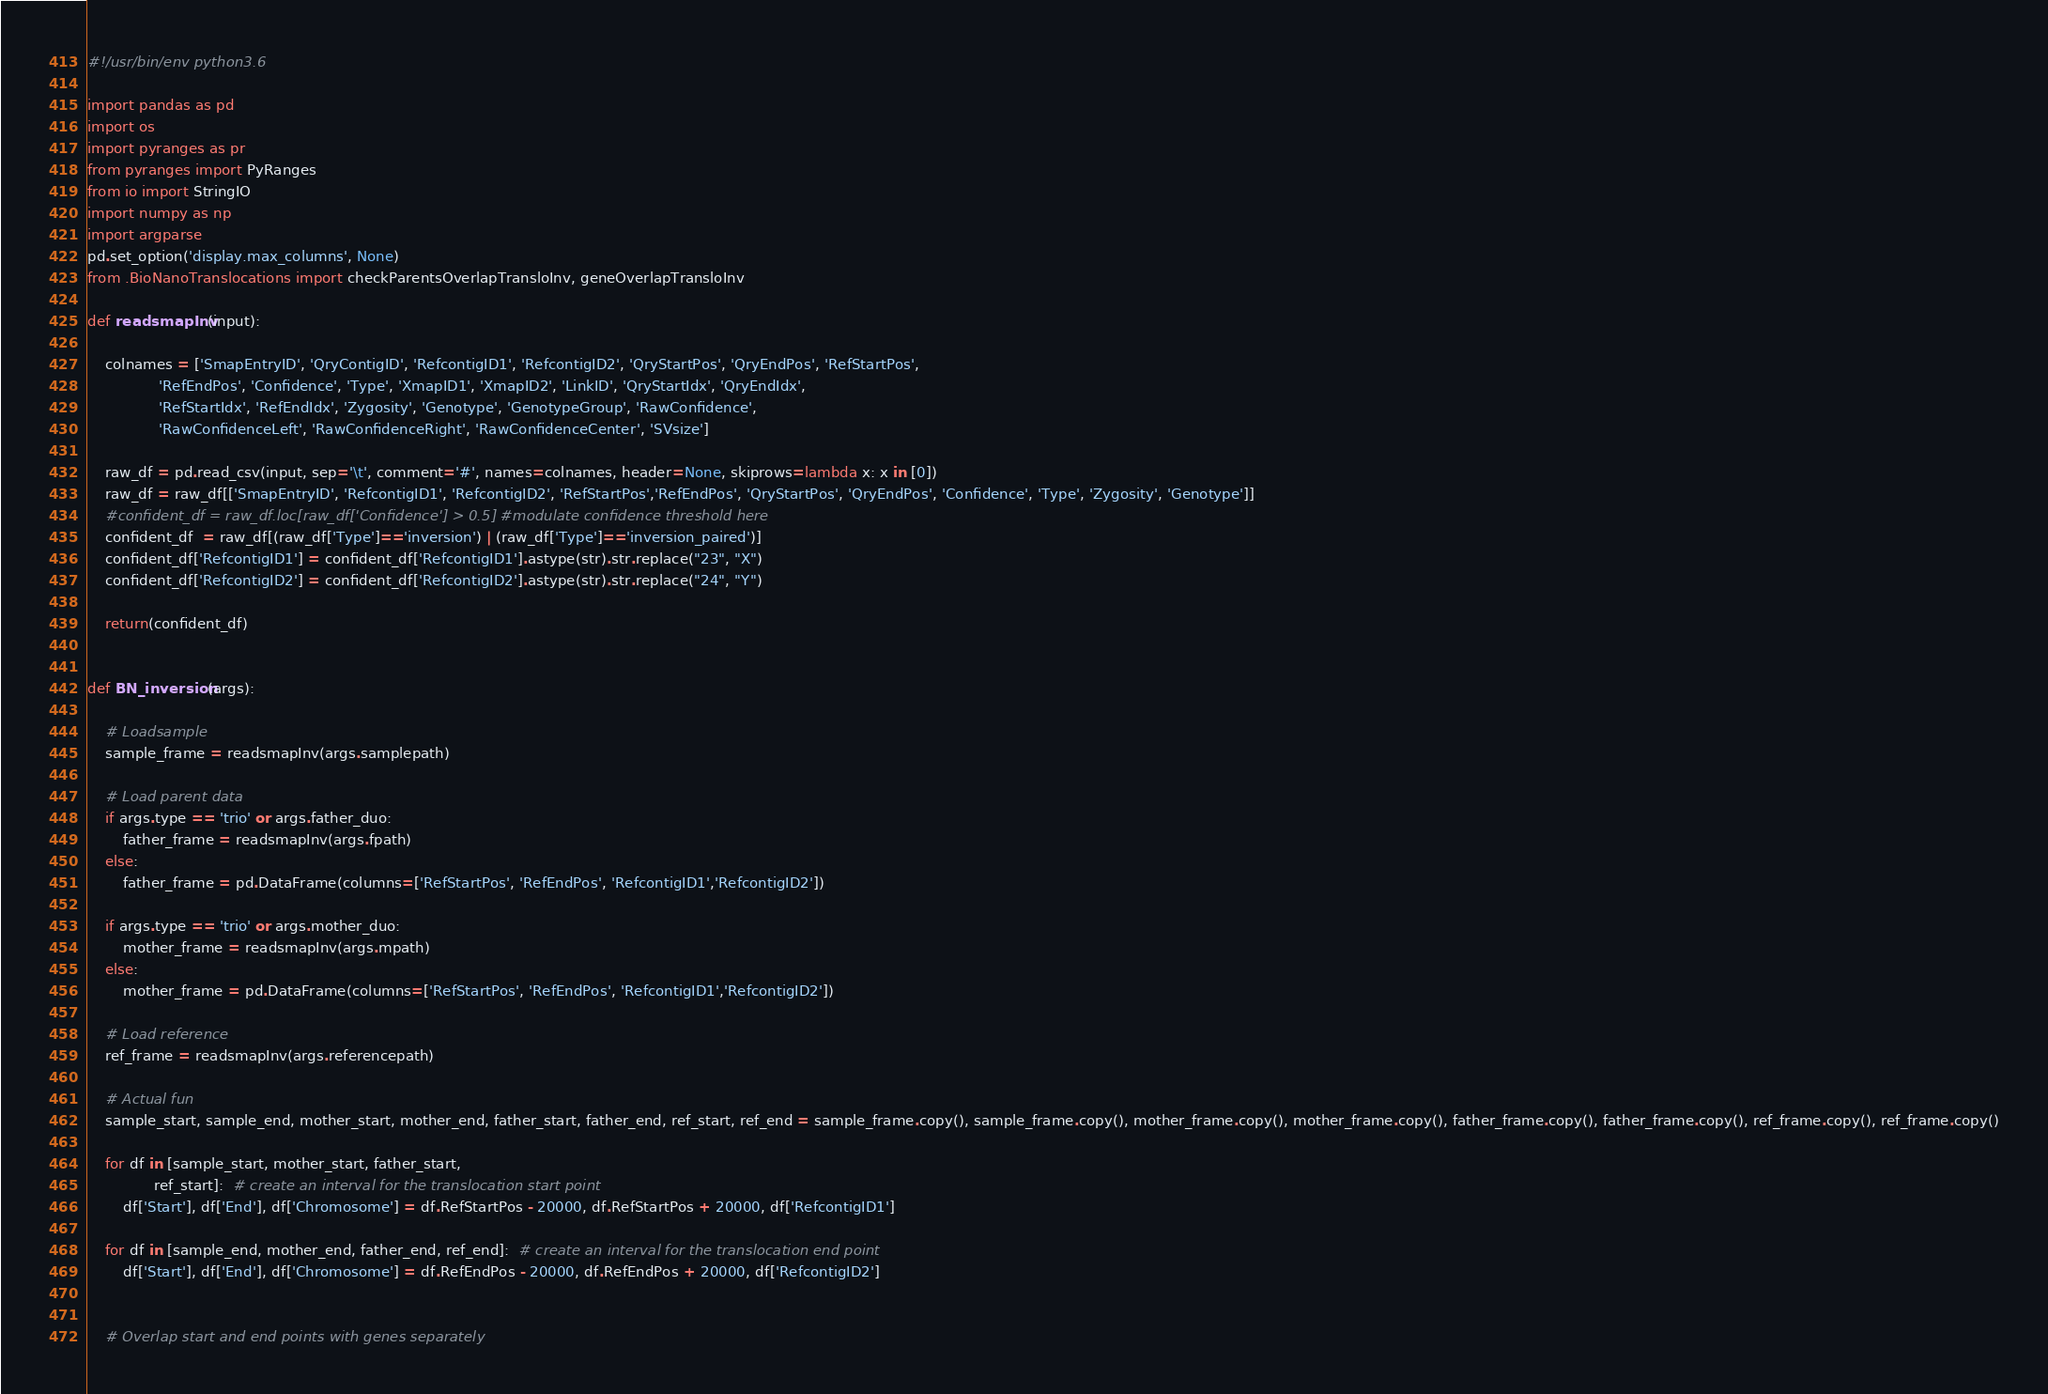Convert code to text. <code><loc_0><loc_0><loc_500><loc_500><_Python_>#!/usr/bin/env python3.6
  
import pandas as pd
import os
import pyranges as pr
from pyranges import PyRanges
from io import StringIO
import numpy as np
import argparse
pd.set_option('display.max_columns', None)
from .BioNanoTranslocations import checkParentsOverlapTransloInv, geneOverlapTransloInv

def readsmapInv(input):

    colnames = ['SmapEntryID', 'QryContigID', 'RefcontigID1', 'RefcontigID2', 'QryStartPos', 'QryEndPos', 'RefStartPos',
                'RefEndPos', 'Confidence', 'Type', 'XmapID1', 'XmapID2', 'LinkID', 'QryStartIdx', 'QryEndIdx',
                'RefStartIdx', 'RefEndIdx', 'Zygosity', 'Genotype', 'GenotypeGroup', 'RawConfidence',
                'RawConfidenceLeft', 'RawConfidenceRight', 'RawConfidenceCenter', 'SVsize']

    raw_df = pd.read_csv(input, sep='\t', comment='#', names=colnames, header=None, skiprows=lambda x: x in [0])
    raw_df = raw_df[['SmapEntryID', 'RefcontigID1', 'RefcontigID2', 'RefStartPos','RefEndPos', 'QryStartPos', 'QryEndPos', 'Confidence', 'Type', 'Zygosity', 'Genotype']]
    #confident_df = raw_df.loc[raw_df['Confidence'] > 0.5] #modulate confidence threshold here
    confident_df  = raw_df[(raw_df['Type']=='inversion') | (raw_df['Type']=='inversion_paired')]
    confident_df['RefcontigID1'] = confident_df['RefcontigID1'].astype(str).str.replace("23", "X")
    confident_df['RefcontigID2'] = confident_df['RefcontigID2'].astype(str).str.replace("24", "Y")

    return(confident_df)


def BN_inversion(args):

    # Loadsample
    sample_frame = readsmapInv(args.samplepath)

    # Load parent data
    if args.type == 'trio' or args.father_duo:
        father_frame = readsmapInv(args.fpath)
    else:
        father_frame = pd.DataFrame(columns=['RefStartPos', 'RefEndPos', 'RefcontigID1','RefcontigID2'])

    if args.type == 'trio' or args.mother_duo:
        mother_frame = readsmapInv(args.mpath)
    else:
        mother_frame = pd.DataFrame(columns=['RefStartPos', 'RefEndPos', 'RefcontigID1','RefcontigID2'])

    # Load reference
    ref_frame = readsmapInv(args.referencepath)

    # Actual fun
    sample_start, sample_end, mother_start, mother_end, father_start, father_end, ref_start, ref_end = sample_frame.copy(), sample_frame.copy(), mother_frame.copy(), mother_frame.copy(), father_frame.copy(), father_frame.copy(), ref_frame.copy(), ref_frame.copy()

    for df in [sample_start, mother_start, father_start,
               ref_start]:  # create an interval for the translocation start point
        df['Start'], df['End'], df['Chromosome'] = df.RefStartPos - 20000, df.RefStartPos + 20000, df['RefcontigID1']

    for df in [sample_end, mother_end, father_end, ref_end]:  # create an interval for the translocation end point
        df['Start'], df['End'], df['Chromosome'] = df.RefEndPos - 20000, df.RefEndPos + 20000, df['RefcontigID2']


    # Overlap start and end points with genes separately</code> 